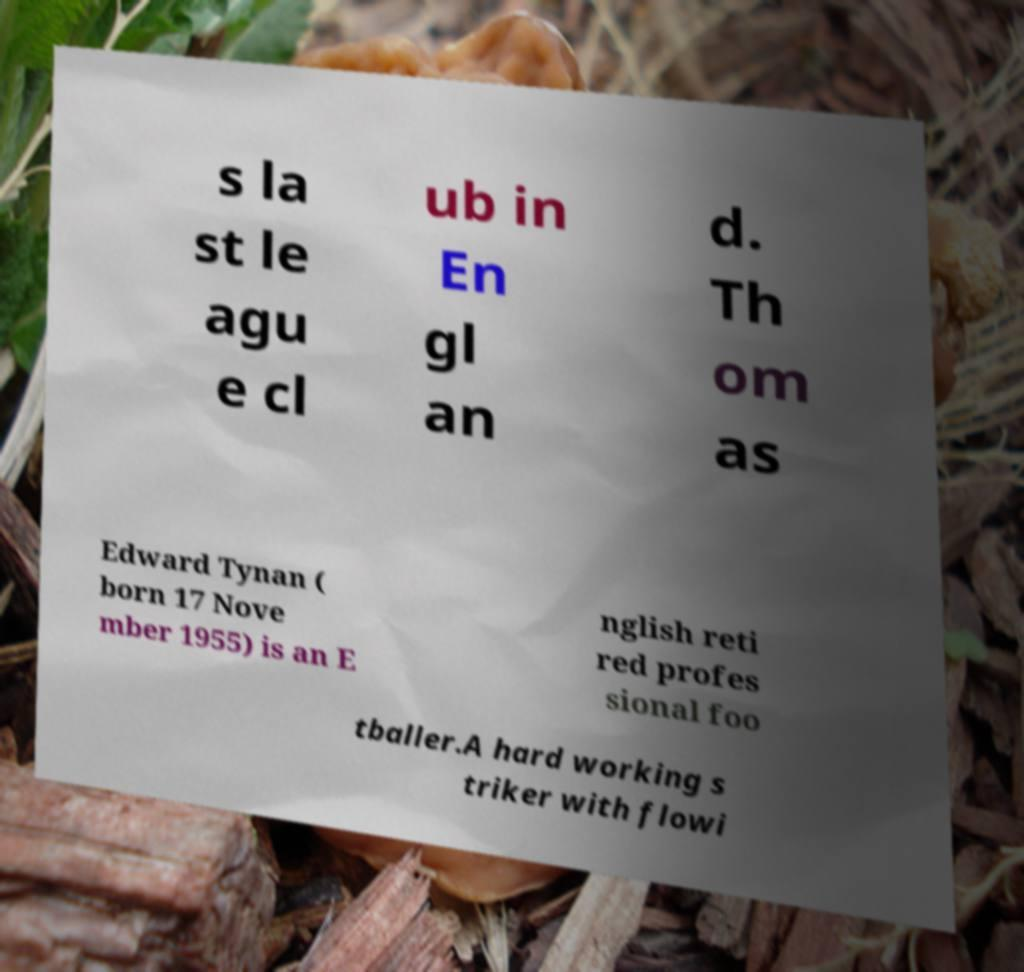Could you assist in decoding the text presented in this image and type it out clearly? s la st le agu e cl ub in En gl an d. Th om as Edward Tynan ( born 17 Nove mber 1955) is an E nglish reti red profes sional foo tballer.A hard working s triker with flowi 